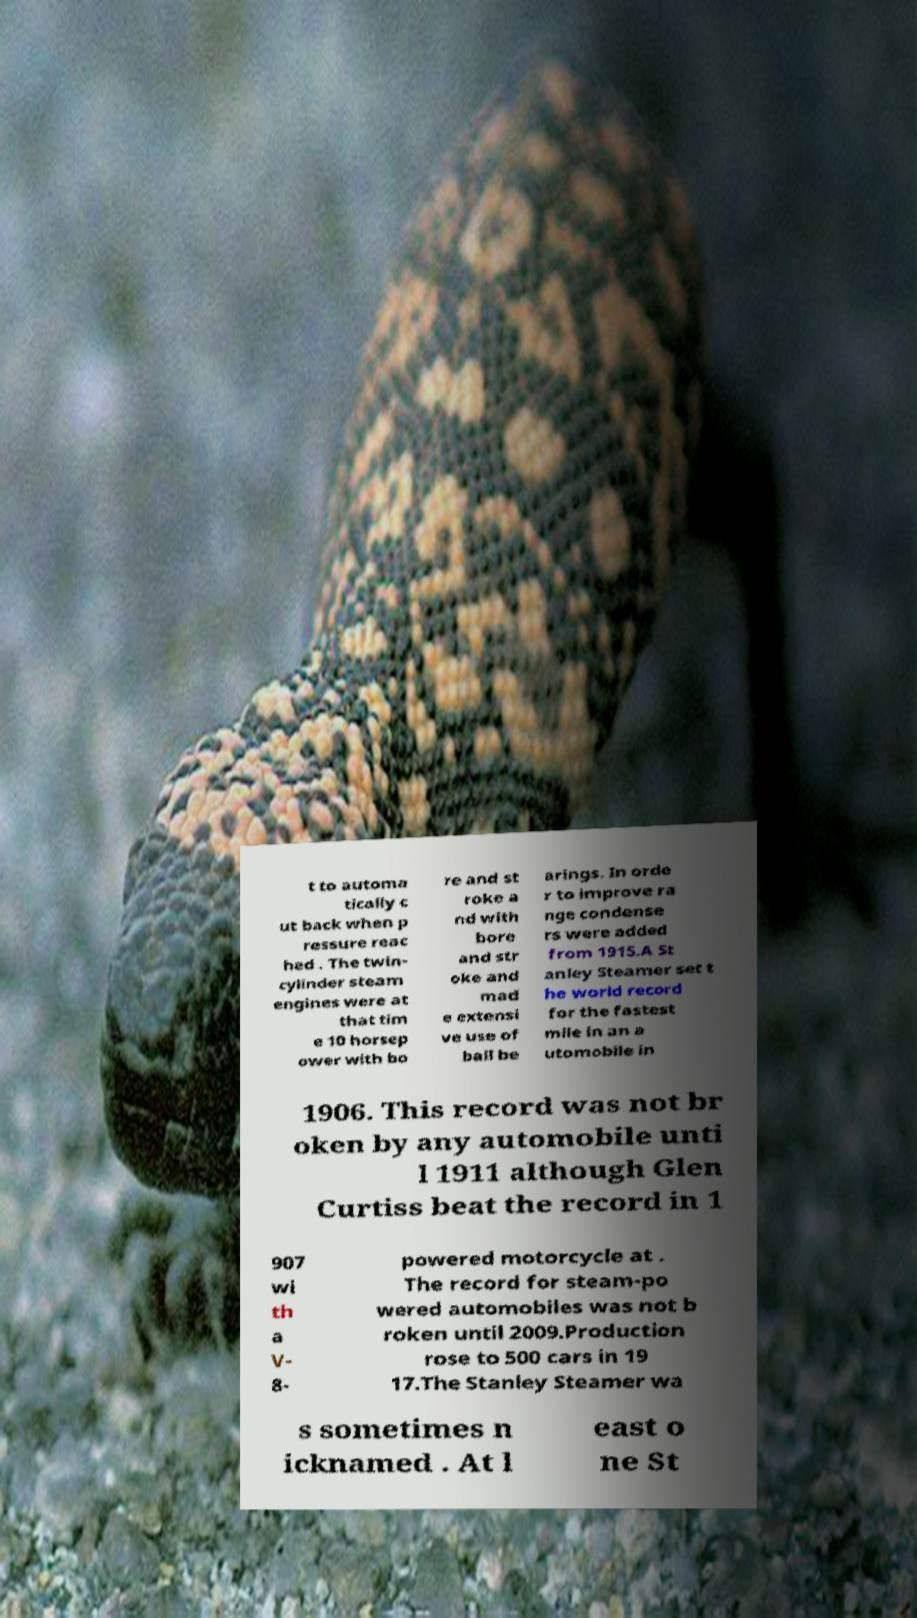I need the written content from this picture converted into text. Can you do that? t to automa tically c ut back when p ressure reac hed . The twin- cylinder steam engines were at that tim e 10 horsep ower with bo re and st roke a nd with bore and str oke and mad e extensi ve use of ball be arings. In orde r to improve ra nge condense rs were added from 1915.A St anley Steamer set t he world record for the fastest mile in an a utomobile in 1906. This record was not br oken by any automobile unti l 1911 although Glen Curtiss beat the record in 1 907 wi th a V- 8- powered motorcycle at . The record for steam-po wered automobiles was not b roken until 2009.Production rose to 500 cars in 19 17.The Stanley Steamer wa s sometimes n icknamed . At l east o ne St 